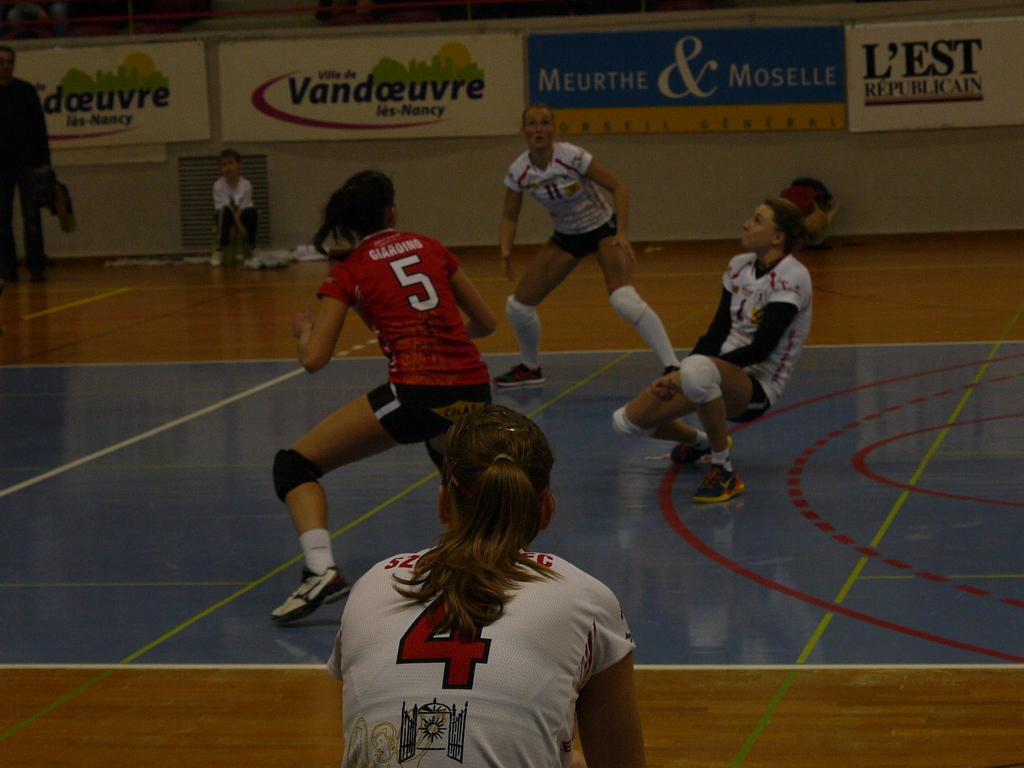Describe this image in one or two sentences. In this image we can see group of persons playing on the floor. In the background we can see persons, wall and advertisements. 